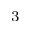<formula> <loc_0><loc_0><loc_500><loc_500>_ { 3 }</formula> 